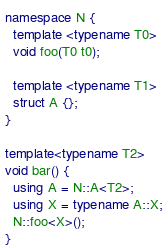<code> <loc_0><loc_0><loc_500><loc_500><_C++_>namespace N {
  template <typename T0>
  void foo(T0 t0);

  template <typename T1>
  struct A {};
}

template<typename T2>
void bar() {
  using A = N::A<T2>;
  using X = typename A::X;
  N::foo<X>();
}
</code> 